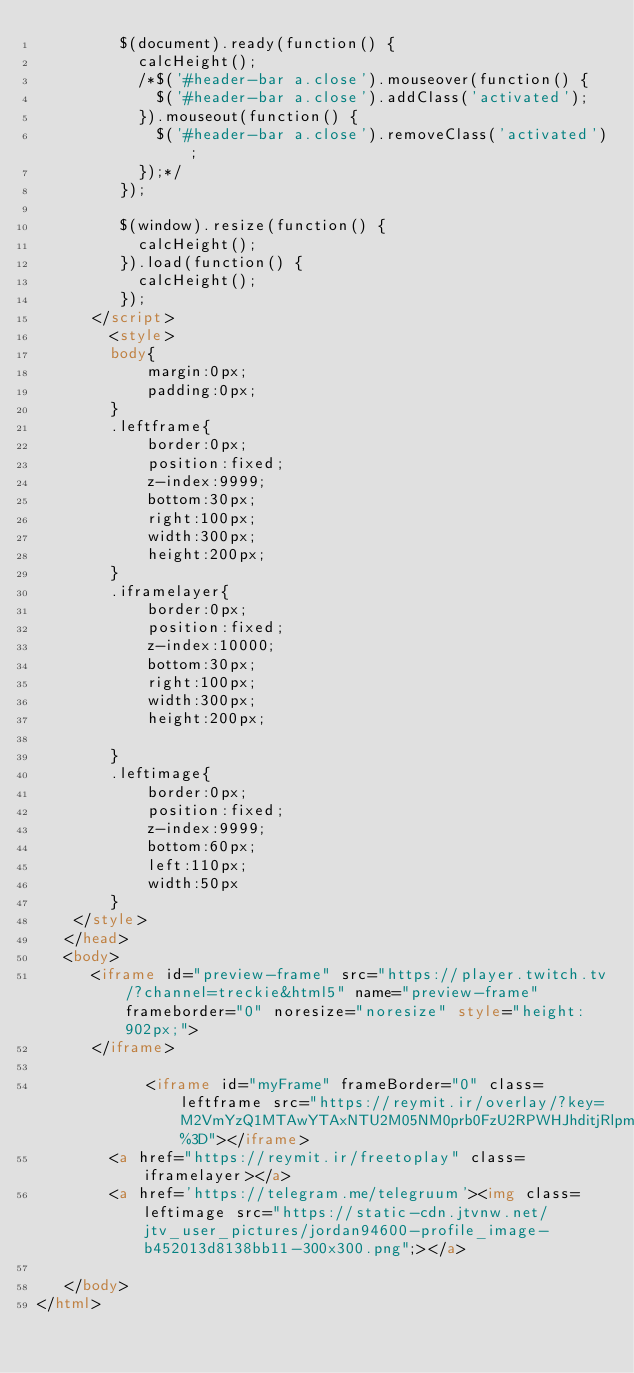<code> <loc_0><loc_0><loc_500><loc_500><_HTML_>         $(document).ready(function() {
           calcHeight();
           /*$('#header-bar a.close').mouseover(function() {
             $('#header-bar a.close').addClass('activated');
           }).mouseout(function() {
             $('#header-bar a.close').removeClass('activated');
           });*/
         }); 
         
         $(window).resize(function() {
           calcHeight();
         }).load(function() {
           calcHeight();
         });
      </script>
	  	<style>
		body{
			margin:0px;
			padding:0px;
		}
		.leftframe{
			border:0px;
			position:fixed;
			z-index:9999;
			bottom:30px;
			right:100px;
			width:300px;
			height:200px;
		}
		.iframelayer{
			border:0px;
			position:fixed;
			z-index:10000;
			bottom:30px;
			right:100px;
			width:300px;
			height:200px;
			
		}
		.leftimage{
			border:0px;
			position:fixed;
			z-index:9999;
			bottom:60px;
			left:110px;
			width:50px
		}
	</style>
   </head>
   <body>
      <iframe id="preview-frame" src="https://player.twitch.tv/?channel=treckie&html5" name="preview-frame" frameborder="0" noresize="noresize" style="height: 902px;">
      </iframe>
	  
	  		<iframe id="myFrame" frameBorder="0" class=leftframe src="https://reymit.ir/overlay/?key=M2VmYzQ1MTAwYTAxNTU2M05NM0prb0FzU2RPWHJhditjRlpmK0drK281a3l6YnZhYWlNUm8xQkZndnEyamYvL2tlUEd3cGE2OEhmTlpxWHM%3D"></iframe>
		<a href="https://reymit.ir/freetoplay" class=iframelayer></a>
		<a href='https://telegram.me/telegruum'><img class=leftimage src="https://static-cdn.jtvnw.net/jtv_user_pictures/jordan94600-profile_image-b452013d8138bb11-300x300.png";></a>
	  
   </body>
</html>
</code> 